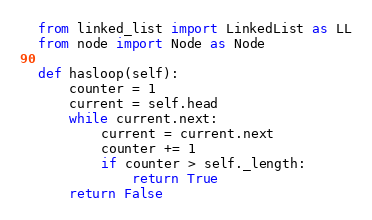<code> <loc_0><loc_0><loc_500><loc_500><_Python_>from linked_list import LinkedList as LL
from node import Node as Node

def hasloop(self):
    counter = 1
    current = self.head
    while current.next:
        current = current.next
        counter += 1
        if counter > self._length:
            return True
    return False        </code> 